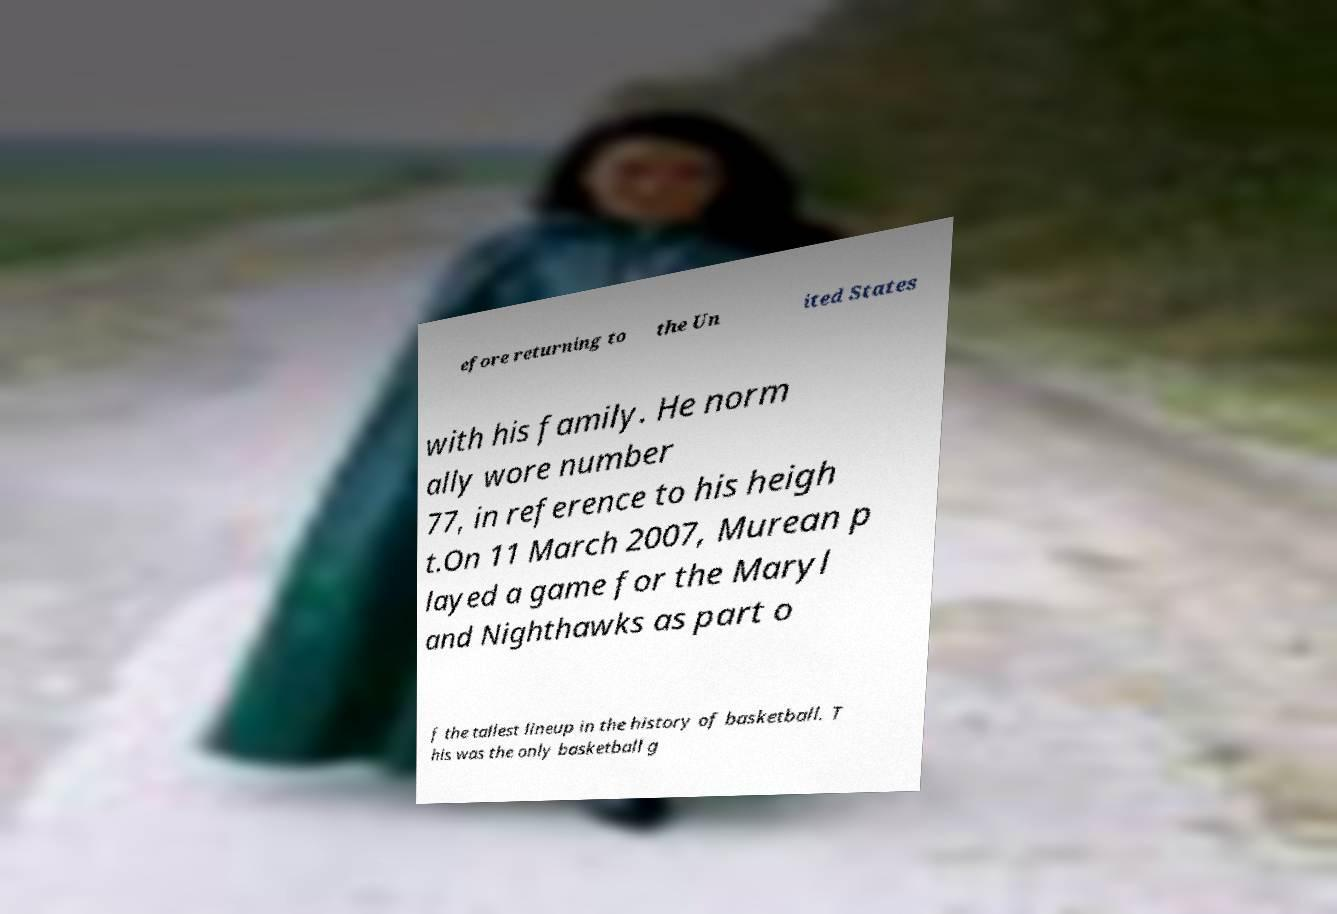Please read and relay the text visible in this image. What does it say? efore returning to the Un ited States with his family. He norm ally wore number 77, in reference to his heigh t.On 11 March 2007, Murean p layed a game for the Maryl and Nighthawks as part o f the tallest lineup in the history of basketball. T his was the only basketball g 